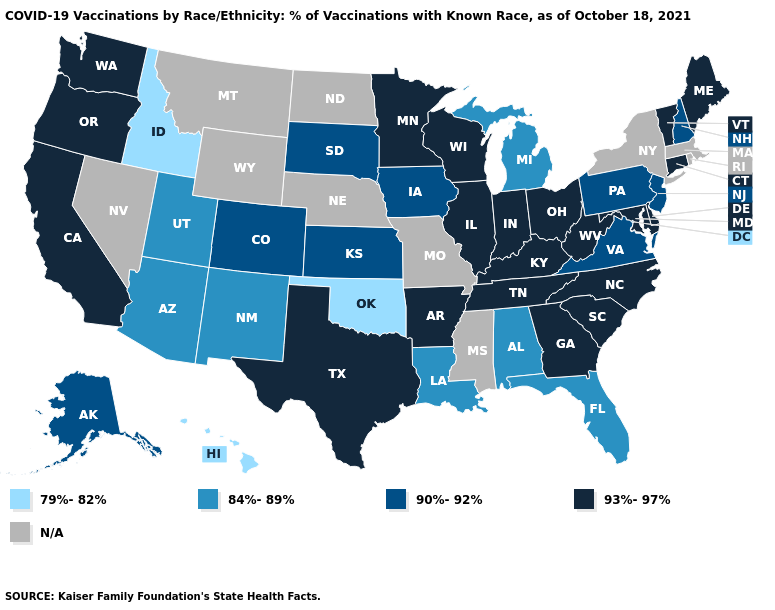Does the map have missing data?
Concise answer only. Yes. Does the map have missing data?
Short answer required. Yes. What is the value of Hawaii?
Be succinct. 79%-82%. What is the highest value in the USA?
Quick response, please. 93%-97%. How many symbols are there in the legend?
Answer briefly. 5. Among the states that border Kansas , does Oklahoma have the lowest value?
Give a very brief answer. Yes. Among the states that border Kansas , does Colorado have the highest value?
Write a very short answer. Yes. Among the states that border West Virginia , which have the highest value?
Answer briefly. Kentucky, Maryland, Ohio. Which states have the highest value in the USA?
Be succinct. Arkansas, California, Connecticut, Delaware, Georgia, Illinois, Indiana, Kentucky, Maine, Maryland, Minnesota, North Carolina, Ohio, Oregon, South Carolina, Tennessee, Texas, Vermont, Washington, West Virginia, Wisconsin. What is the lowest value in the South?
Give a very brief answer. 79%-82%. What is the value of Kansas?
Short answer required. 90%-92%. What is the highest value in the USA?
Keep it brief. 93%-97%. Among the states that border Arizona , does California have the highest value?
Short answer required. Yes. Does Texas have the highest value in the USA?
Keep it brief. Yes. What is the value of Arkansas?
Write a very short answer. 93%-97%. 